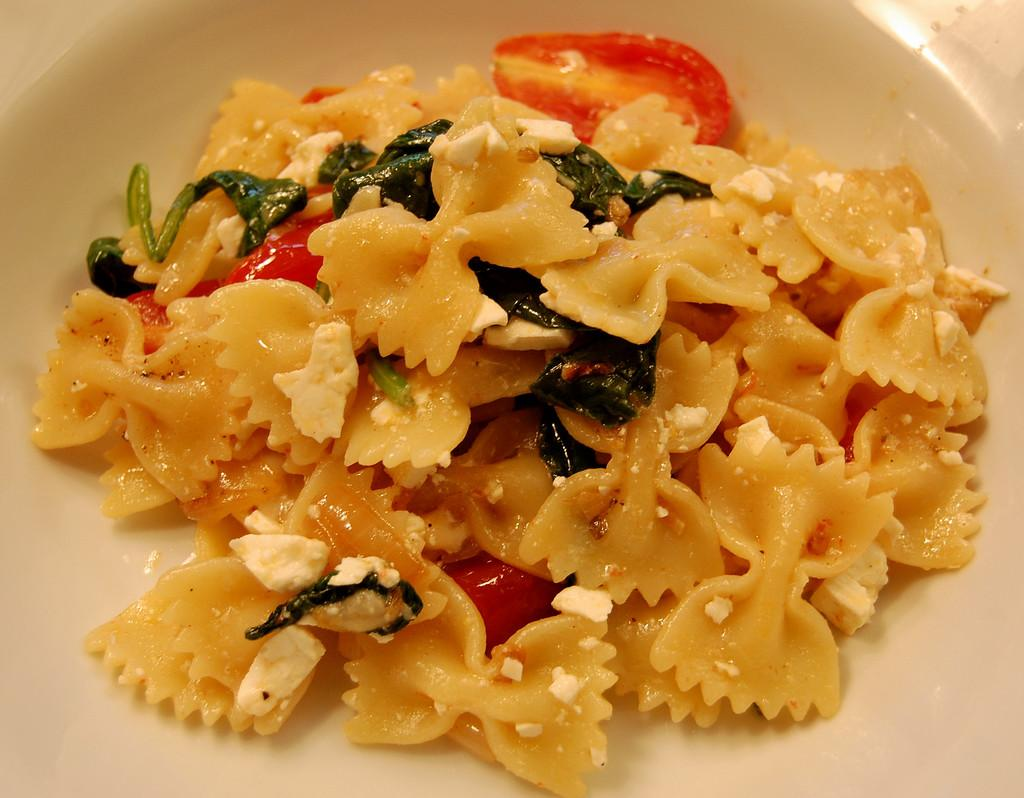What is present on the plate in the image? There is a food item on the plate in the image. Can you describe the food item on the plate? Unfortunately, the specific food item cannot be determined from the provided facts. What type of engine is visible in the image? There is no engine present in the image; it only features a plate with a food item on it. 